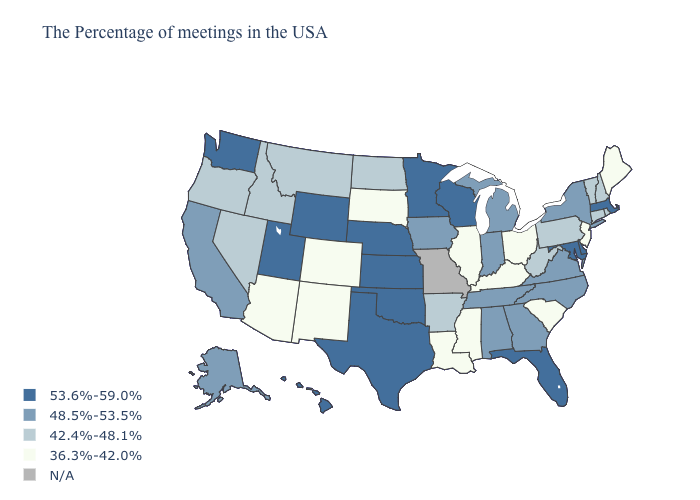Does the map have missing data?
Concise answer only. Yes. What is the value of Hawaii?
Concise answer only. 53.6%-59.0%. Does New Jersey have the lowest value in the Northeast?
Short answer required. Yes. Does the first symbol in the legend represent the smallest category?
Be succinct. No. Does Maryland have the highest value in the USA?
Answer briefly. Yes. Name the states that have a value in the range N/A?
Write a very short answer. Missouri. Name the states that have a value in the range 53.6%-59.0%?
Give a very brief answer. Massachusetts, Delaware, Maryland, Florida, Wisconsin, Minnesota, Kansas, Nebraska, Oklahoma, Texas, Wyoming, Utah, Washington, Hawaii. What is the value of Pennsylvania?
Write a very short answer. 42.4%-48.1%. Among the states that border Michigan , does Indiana have the lowest value?
Keep it brief. No. Does California have the highest value in the USA?
Write a very short answer. No. Does Louisiana have the lowest value in the USA?
Answer briefly. Yes. Name the states that have a value in the range 42.4%-48.1%?
Write a very short answer. Rhode Island, New Hampshire, Vermont, Connecticut, Pennsylvania, West Virginia, Arkansas, North Dakota, Montana, Idaho, Nevada, Oregon. Among the states that border Minnesota , which have the highest value?
Short answer required. Wisconsin. 